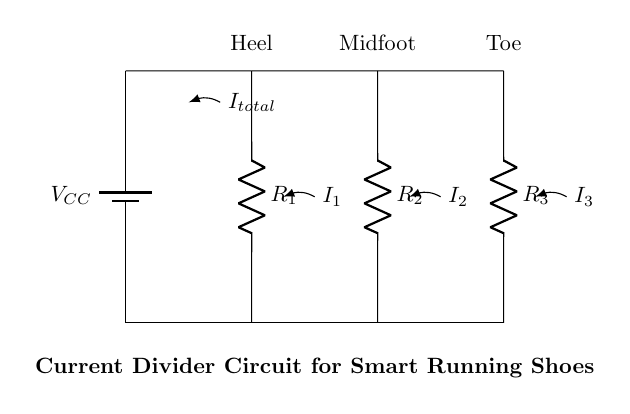What is the total current flowing in the circuit? The total current is designated as I_total in the diagram, which is entering the parallel branches formed by the resistors.
Answer: I_total What are the three pressure sensor locations represented in the circuit? The circuit shows three pressure sensor locations labeled as Heel, Midfoot, and Toe. Each corresponds to a resistor in the parallel branches.
Answer: Heel, Midfoot, Toe What type of circuit configuration is used in this design? The diagram depicts a parallel circuit configuration where multiple resistors (R_1, R_2, R_3) are connected side by side across the voltage source.
Answer: Parallel How does the current distribute among the branches? In a current divider, the total current splits across the parallel branches based on the resistances. The branch with the lowest resistance will carry the highest current, following the current divider rule.
Answer: Based on resistance Which resistor represents the pedal pressure sensor for the heel? In the circuit, R_1 is designated as the pressure sensor for the heel, as it's the first resistor connected to the heel location.
Answer: R_1 What happens if one of the resistors is removed from the circuit? If one resistor is removed, the total current will alter, leading to a change in current distribution as the remaining resistors will now share the total current. The overall resistance of the circuit will decrease, leading to an increase in total current from the voltage source.
Answer: Total current increases 